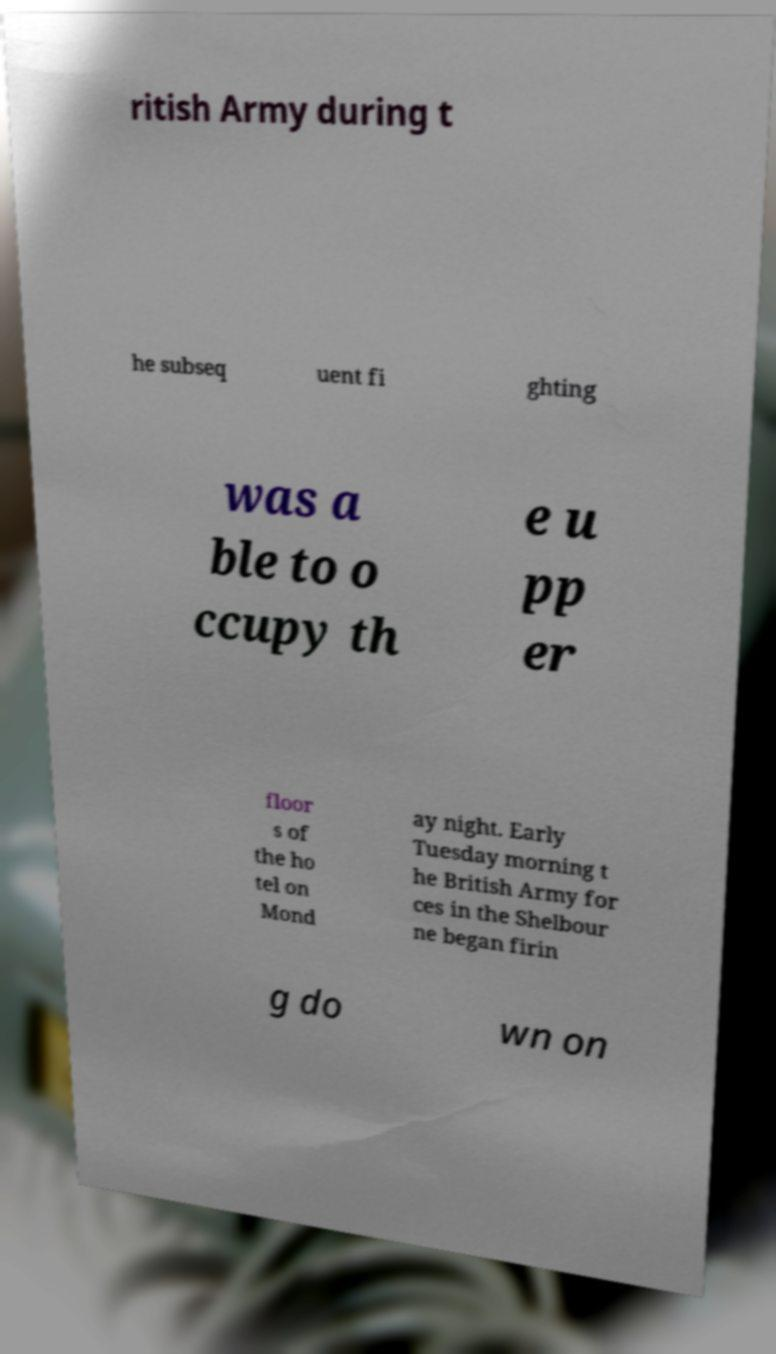Could you extract and type out the text from this image? ritish Army during t he subseq uent fi ghting was a ble to o ccupy th e u pp er floor s of the ho tel on Mond ay night. Early Tuesday morning t he British Army for ces in the Shelbour ne began firin g do wn on 